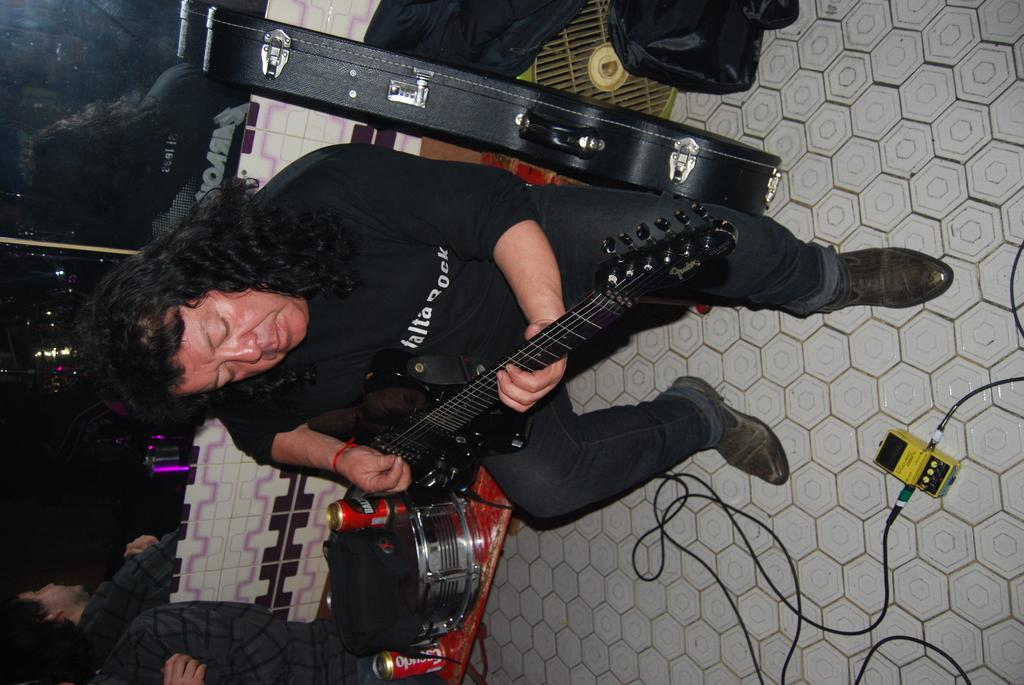What is the main subject of the image? The main subject of the image is a man. What is the man doing in the image? The man is sitting on a bench and playing a guitar. What type of flag is visible in the image? There is no flag present in the image. What color is the ink used by the man in the image? The man is playing a guitar, not using ink, so there is no ink to describe in the image. 